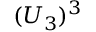Convert formula to latex. <formula><loc_0><loc_0><loc_500><loc_500>( U _ { 3 } ) ^ { 3 }</formula> 